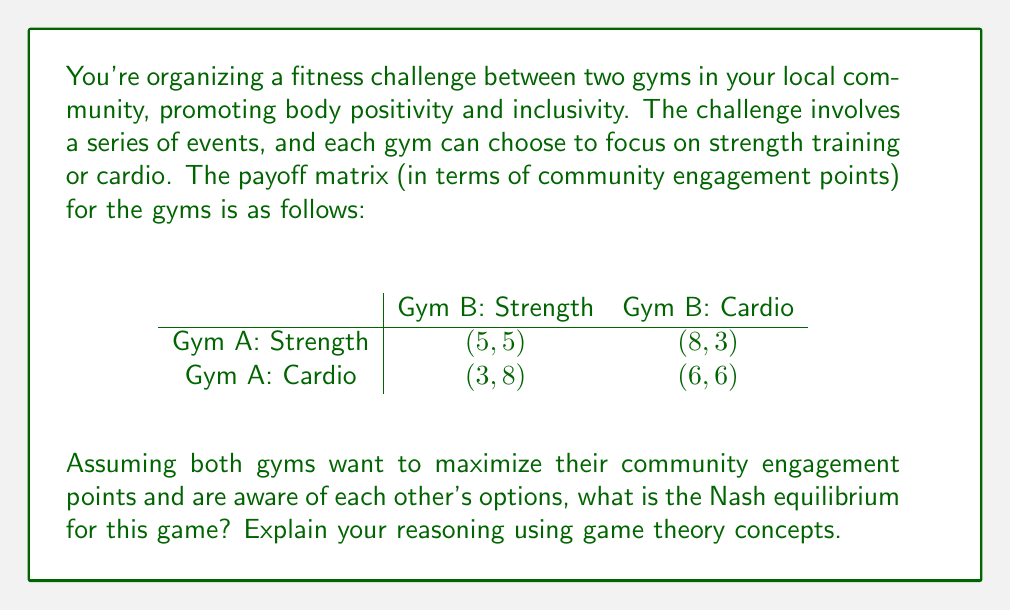Can you answer this question? To find the Nash equilibrium, we need to analyze each gym's best response to the other's strategy:

1. For Gym A:
   - If Gym B chooses Strength, Gym A's best response is Strength (5 > 3)
   - If Gym B chooses Cardio, Gym A's best response is Strength (8 > 6)

2. For Gym B:
   - If Gym A chooses Strength, Gym B's best response is Cardio (8 > 5)
   - If Gym A chooses Cardio, Gym B's best response is Strength (8 > 6)

3. Nash equilibrium occurs when each player's strategy is the best response to the other player's strategy.

4. In this case, we see that (Strength, Cardio) is a Nash equilibrium:
   - Gym A chooses Strength, which is the best response to Gym B's Cardio
   - Gym B chooses Cardio, which is the best response to Gym A's Strength

5. This is the only Nash equilibrium in pure strategies for this game.

6. The outcome (8, 3) represents the payoffs for Gym A and Gym B respectively when they play their Nash equilibrium strategies.

This equilibrium showcases how different fitness approaches can coexist and complement each other in a community, aligning with the body positivity message by emphasizing diverse fitness options.
Answer: (Strength, Cardio) 